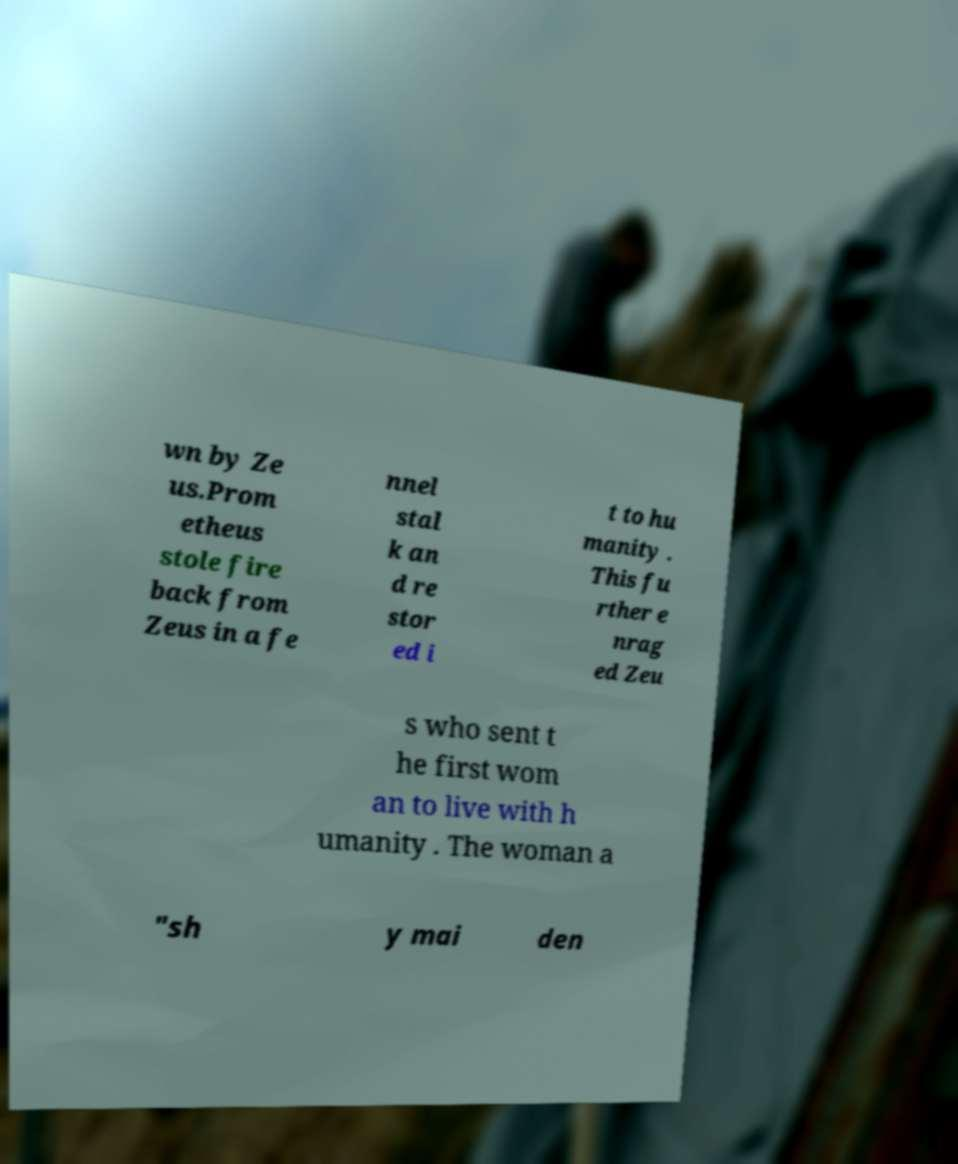Could you extract and type out the text from this image? wn by Ze us.Prom etheus stole fire back from Zeus in a fe nnel stal k an d re stor ed i t to hu manity . This fu rther e nrag ed Zeu s who sent t he first wom an to live with h umanity . The woman a "sh y mai den 